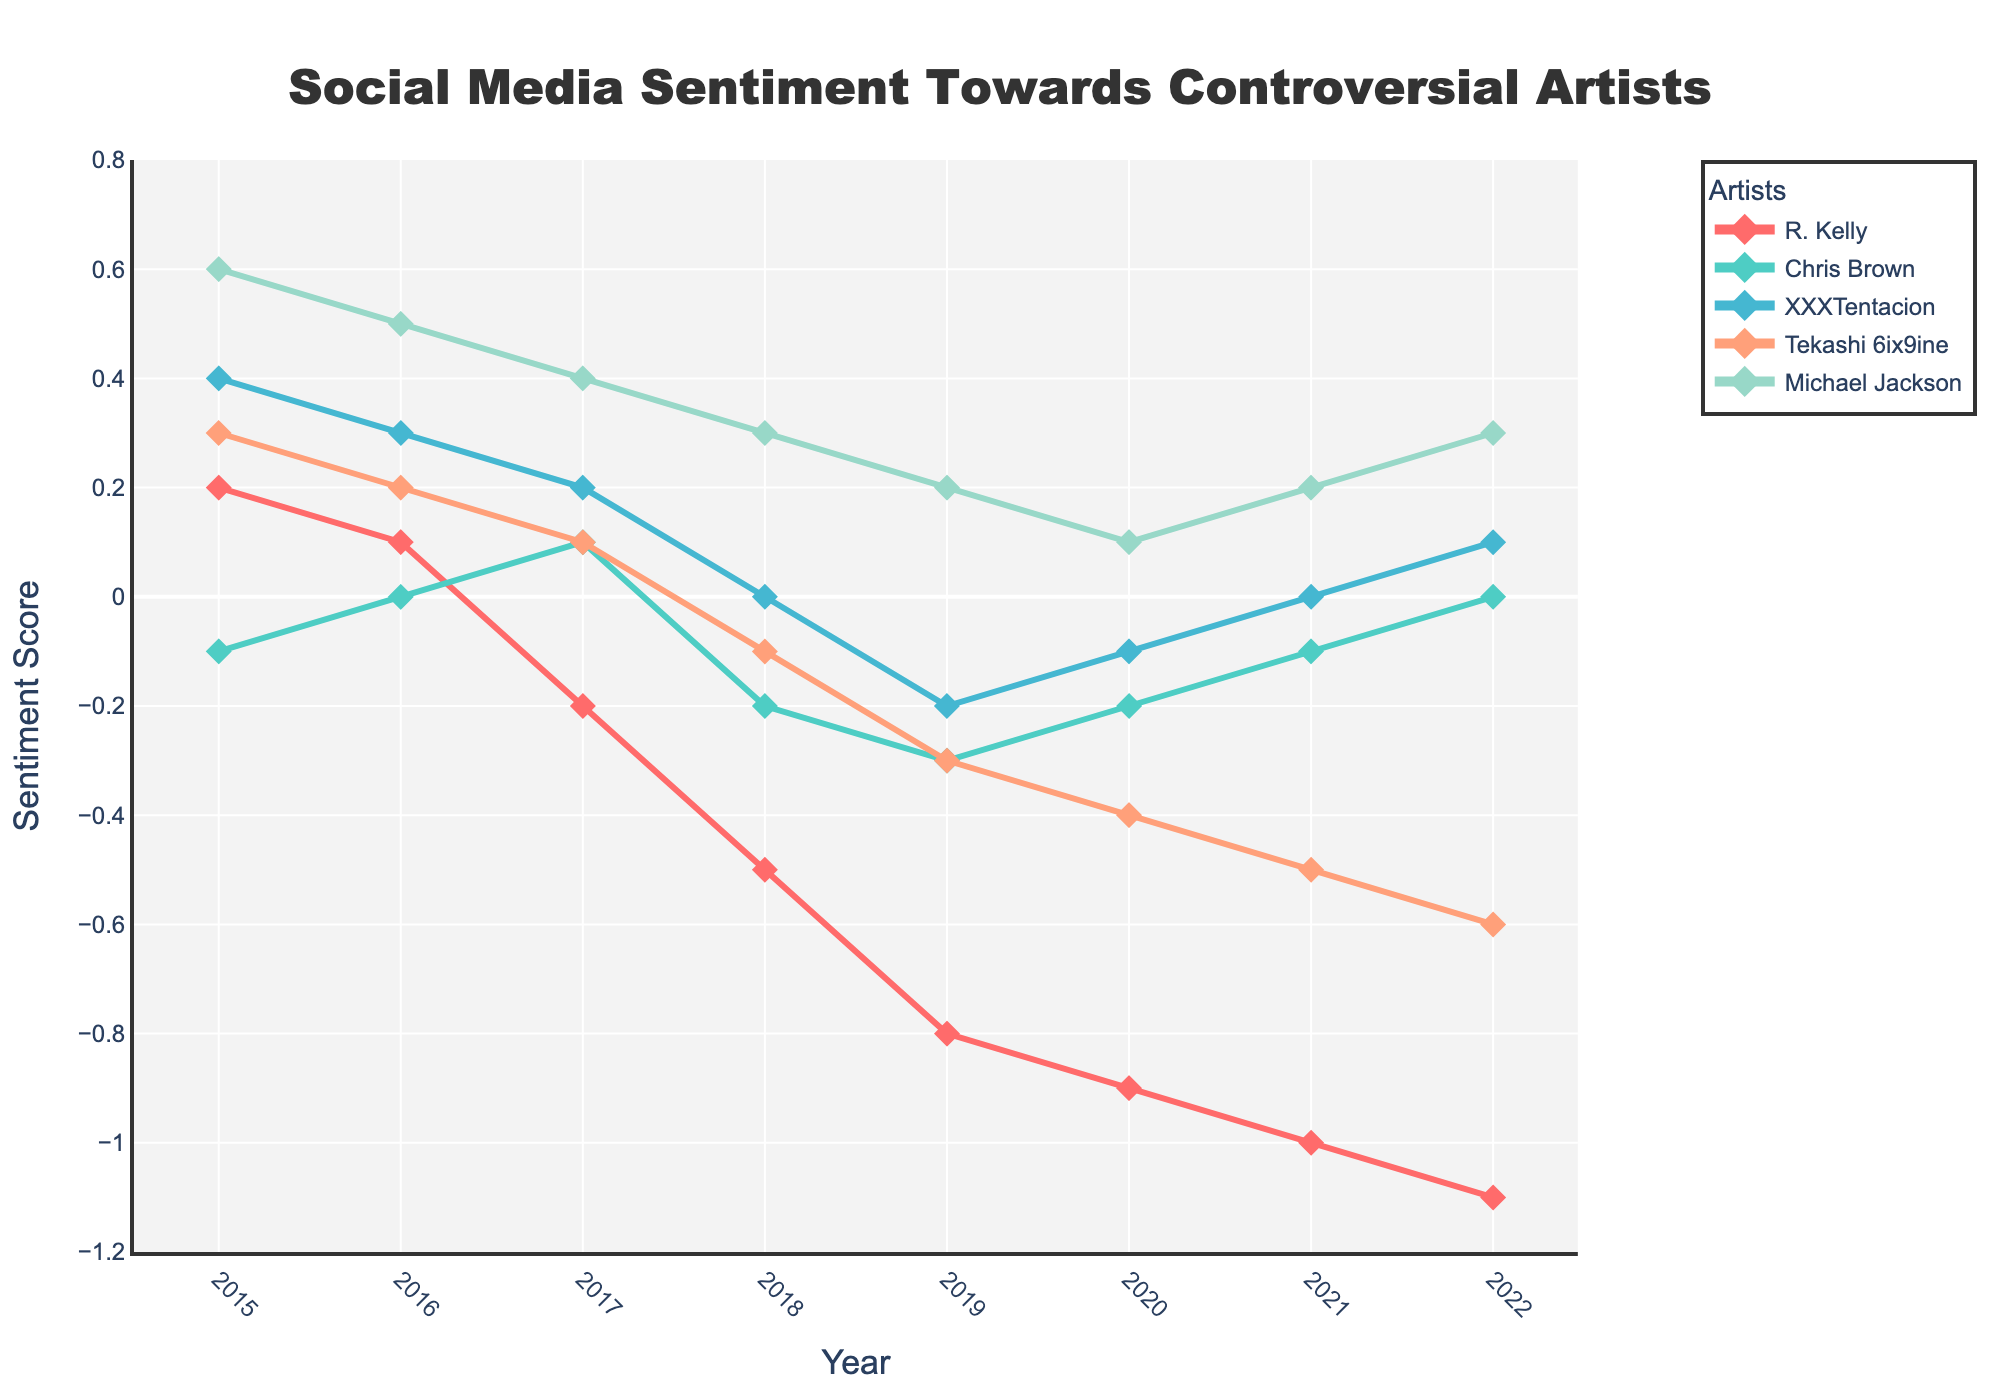What's the trend in the sentiment scores for R. Kelly from 2015 to 2022? The sentiment score for R. Kelly decreases steadily from 0.2 in 2015 to -1.1 in 2022. Each year, the score becomes more negative.
Answer: It steadily decreases How does the sentiment score of Michael Jackson compare to R. Kelly in 2020? The sentiment score for Michael Jackson in 2020 is 0.1, while for R. Kelly, it is -0.9. Michael Jackson's score is higher than R. Kelly's.
Answer: Michael Jackson's score is higher What is the difference in sentiment scores between Chris Brown and XXXTentacion in 2017? In 2017, the sentiment score for Chris Brown is 0.1, and for XXXTentacion, it is 0.2. The difference is 0.2 - 0.1.
Answer: 0.1 Which artist has the most consistent sentiment score trend from 2015 to 2022? Michael Jackson shows the most consistent trend, with the sentiment score only gradually decreasing from 0.6 in 2015 to 0.3 in 2022. Other artists demonstrate larger fluctuations.
Answer: Michael Jackson In which year did Tekashi 6ix9ine have the lowest sentiment score recorded? Tekashi 6ix9ine had the lowest sentiment score of -0.6 in the year 2022.
Answer: 2022 What is the average sentiment score for XXXTentacion over the given period? The sentiment scores for XXXTentacion need to be summed (0.4 + 0.3 + 0.2 + 0.0 - 0.2 - 0.1 + 0.0 + 0.1 = 0.7) and then divided by 8 (number of years). 0.7 / 8 = 0.0875.
Answer: 0.0875 How does the sentiment trend of Chris Brown differ from that of R. Kelly? Chris Brown's sentiment score improves from -0.1 in 2015 to 0.0 in 2022, showing minor fluctuations. In contrast, R. Kelly’s sentiment score steadily decreases from 0.2 in 2015 to -1.1 in 2022, showing a clear downward trend.
Answer: Chris Brown's trend improves; R. Kelly's declines Which year did Chris Brown have the same sentiment score as Michael Jackson? In 2022, both Chris Brown and Michael Jackson have the same sentiment score of 0.3.
Answer: 2022 What's the combined sentiment score for all artists in 2018? Summing the scores for 2018: R. Kelly (-0.5) + Chris Brown (-0.2) + XXXTentacion (0.0) + Tekashi 6ix9ine (-0.1) + Michael Jackson (0.3) = -0.5 - 0.2 + 0.0 - 0.1 + 0.3 = -0.5.
Answer: -0.5 In 2019, how did sentiment scores for controversial artists generally change compared to 2018? Compare each artist's sentiment score from 2018 to 2019: R. Kelly (-0.5 to -0.8), Chris Brown (-0.2 to -0.3), XXXTentacion (0.0 to -0.2), Tekashi 6ix9ine (-0.1 to -0.3), and Michael Jackson (0.3 to 0.2). Most scores became more negative except for Michael Jackson.
Answer: Most scores became more negative 